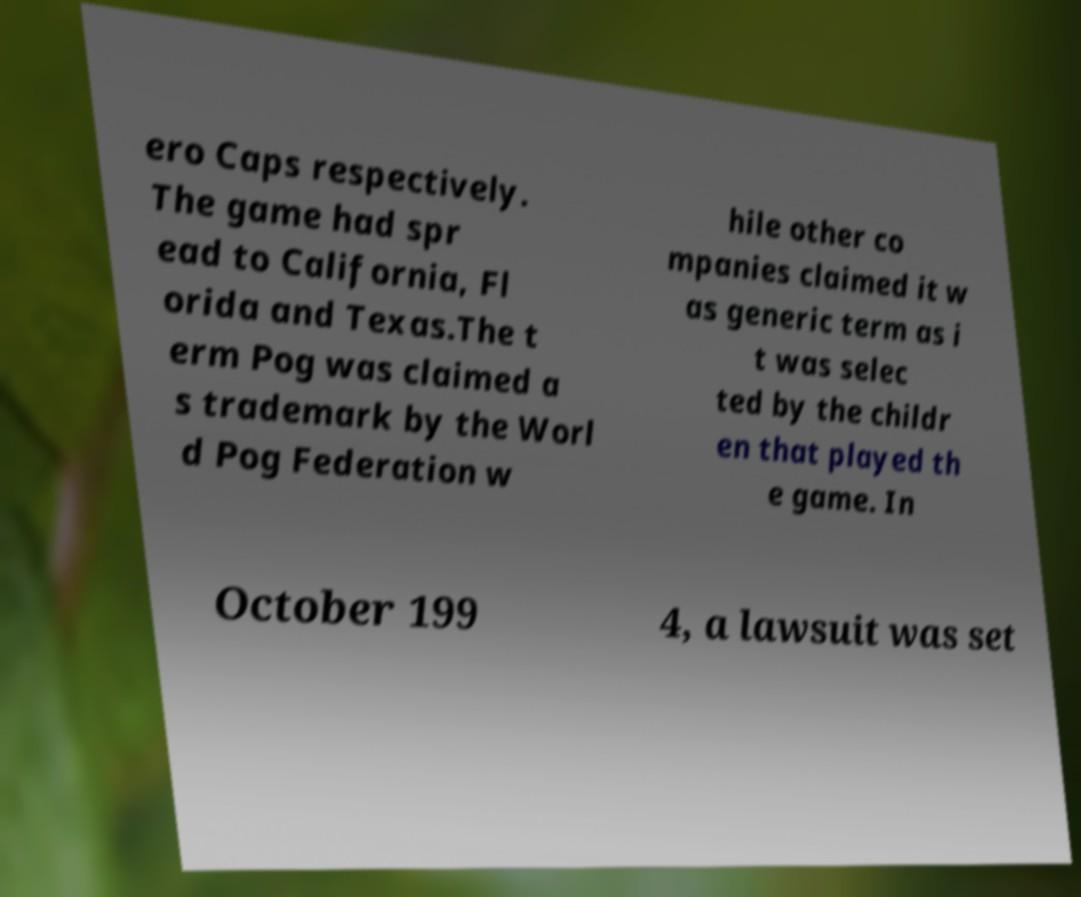Can you accurately transcribe the text from the provided image for me? ero Caps respectively. The game had spr ead to California, Fl orida and Texas.The t erm Pog was claimed a s trademark by the Worl d Pog Federation w hile other co mpanies claimed it w as generic term as i t was selec ted by the childr en that played th e game. In October 199 4, a lawsuit was set 